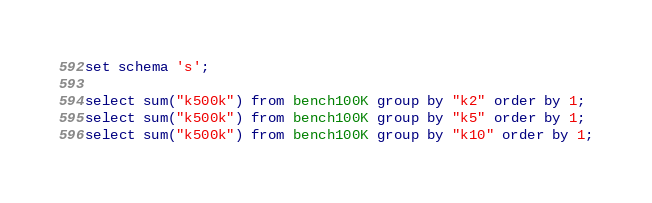Convert code to text. <code><loc_0><loc_0><loc_500><loc_500><_SQL_>set schema 's';

select sum("k500k") from bench100K group by "k2" order by 1;
select sum("k500k") from bench100K group by "k5" order by 1;
select sum("k500k") from bench100K group by "k10" order by 1;</code> 